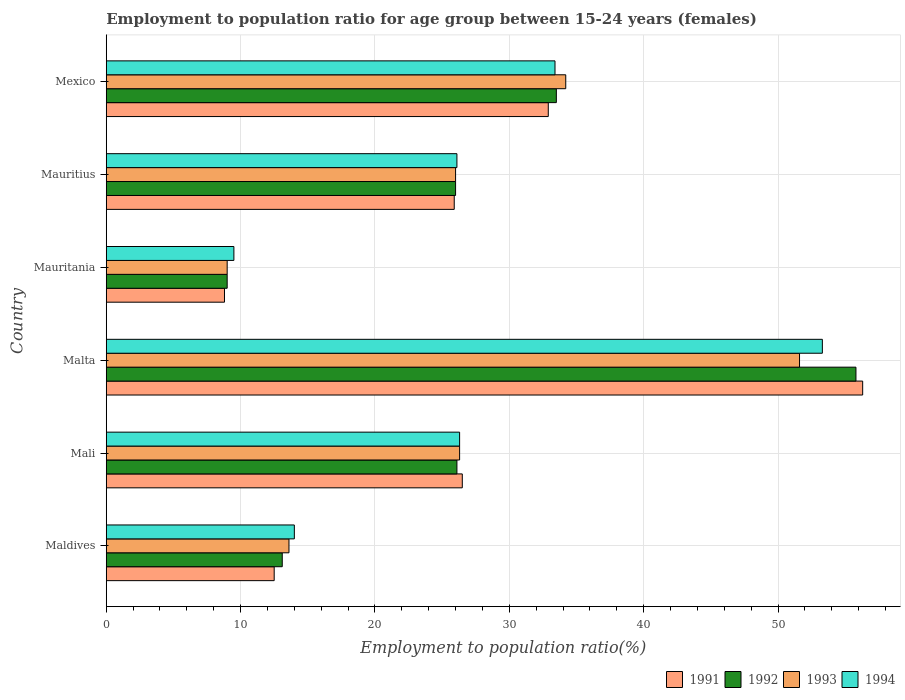How many groups of bars are there?
Your response must be concise. 6. Are the number of bars per tick equal to the number of legend labels?
Offer a terse response. Yes. What is the label of the 5th group of bars from the top?
Your answer should be very brief. Mali. What is the employment to population ratio in 1994 in Malta?
Give a very brief answer. 53.3. Across all countries, what is the maximum employment to population ratio in 1992?
Provide a short and direct response. 55.8. Across all countries, what is the minimum employment to population ratio in 1991?
Your answer should be compact. 8.8. In which country was the employment to population ratio in 1992 maximum?
Your answer should be very brief. Malta. In which country was the employment to population ratio in 1992 minimum?
Your answer should be very brief. Mauritania. What is the total employment to population ratio in 1994 in the graph?
Provide a short and direct response. 162.6. What is the difference between the employment to population ratio in 1991 in Mauritania and that in Mexico?
Your answer should be very brief. -24.1. What is the difference between the employment to population ratio in 1993 in Mauritania and the employment to population ratio in 1991 in Maldives?
Your response must be concise. -3.5. What is the average employment to population ratio in 1994 per country?
Offer a very short reply. 27.1. In how many countries, is the employment to population ratio in 1994 greater than 20 %?
Give a very brief answer. 4. What is the ratio of the employment to population ratio in 1993 in Mauritania to that in Mauritius?
Provide a succinct answer. 0.35. Is the employment to population ratio in 1992 in Malta less than that in Mauritania?
Provide a short and direct response. No. What is the difference between the highest and the second highest employment to population ratio in 1992?
Provide a succinct answer. 22.3. What is the difference between the highest and the lowest employment to population ratio in 1994?
Provide a short and direct response. 43.8. In how many countries, is the employment to population ratio in 1994 greater than the average employment to population ratio in 1994 taken over all countries?
Provide a short and direct response. 2. What does the 2nd bar from the top in Mauritania represents?
Offer a very short reply. 1993. What does the 2nd bar from the bottom in Malta represents?
Your answer should be very brief. 1992. How many bars are there?
Offer a very short reply. 24. What is the difference between two consecutive major ticks on the X-axis?
Make the answer very short. 10. Are the values on the major ticks of X-axis written in scientific E-notation?
Keep it short and to the point. No. How many legend labels are there?
Provide a short and direct response. 4. What is the title of the graph?
Offer a very short reply. Employment to population ratio for age group between 15-24 years (females). Does "1976" appear as one of the legend labels in the graph?
Provide a short and direct response. No. What is the Employment to population ratio(%) in 1991 in Maldives?
Make the answer very short. 12.5. What is the Employment to population ratio(%) in 1992 in Maldives?
Provide a short and direct response. 13.1. What is the Employment to population ratio(%) in 1993 in Maldives?
Your answer should be compact. 13.6. What is the Employment to population ratio(%) in 1994 in Maldives?
Provide a short and direct response. 14. What is the Employment to population ratio(%) in 1992 in Mali?
Your answer should be very brief. 26.1. What is the Employment to population ratio(%) in 1993 in Mali?
Ensure brevity in your answer.  26.3. What is the Employment to population ratio(%) in 1994 in Mali?
Your response must be concise. 26.3. What is the Employment to population ratio(%) in 1991 in Malta?
Provide a succinct answer. 56.3. What is the Employment to population ratio(%) in 1992 in Malta?
Keep it short and to the point. 55.8. What is the Employment to population ratio(%) of 1993 in Malta?
Keep it short and to the point. 51.6. What is the Employment to population ratio(%) of 1994 in Malta?
Your answer should be very brief. 53.3. What is the Employment to population ratio(%) of 1991 in Mauritania?
Your answer should be compact. 8.8. What is the Employment to population ratio(%) of 1992 in Mauritania?
Keep it short and to the point. 9. What is the Employment to population ratio(%) of 1994 in Mauritania?
Offer a very short reply. 9.5. What is the Employment to population ratio(%) of 1991 in Mauritius?
Keep it short and to the point. 25.9. What is the Employment to population ratio(%) of 1992 in Mauritius?
Ensure brevity in your answer.  26. What is the Employment to population ratio(%) of 1994 in Mauritius?
Make the answer very short. 26.1. What is the Employment to population ratio(%) of 1991 in Mexico?
Keep it short and to the point. 32.9. What is the Employment to population ratio(%) of 1992 in Mexico?
Ensure brevity in your answer.  33.5. What is the Employment to population ratio(%) in 1993 in Mexico?
Your answer should be compact. 34.2. What is the Employment to population ratio(%) of 1994 in Mexico?
Provide a short and direct response. 33.4. Across all countries, what is the maximum Employment to population ratio(%) in 1991?
Your answer should be compact. 56.3. Across all countries, what is the maximum Employment to population ratio(%) in 1992?
Your answer should be compact. 55.8. Across all countries, what is the maximum Employment to population ratio(%) of 1993?
Keep it short and to the point. 51.6. Across all countries, what is the maximum Employment to population ratio(%) of 1994?
Your response must be concise. 53.3. Across all countries, what is the minimum Employment to population ratio(%) in 1991?
Make the answer very short. 8.8. Across all countries, what is the minimum Employment to population ratio(%) in 1992?
Ensure brevity in your answer.  9. Across all countries, what is the minimum Employment to population ratio(%) in 1993?
Provide a succinct answer. 9. Across all countries, what is the minimum Employment to population ratio(%) in 1994?
Give a very brief answer. 9.5. What is the total Employment to population ratio(%) in 1991 in the graph?
Make the answer very short. 162.9. What is the total Employment to population ratio(%) in 1992 in the graph?
Give a very brief answer. 163.5. What is the total Employment to population ratio(%) of 1993 in the graph?
Offer a very short reply. 160.7. What is the total Employment to population ratio(%) in 1994 in the graph?
Offer a very short reply. 162.6. What is the difference between the Employment to population ratio(%) in 1991 in Maldives and that in Mali?
Offer a very short reply. -14. What is the difference between the Employment to population ratio(%) of 1992 in Maldives and that in Mali?
Provide a succinct answer. -13. What is the difference between the Employment to population ratio(%) of 1991 in Maldives and that in Malta?
Your answer should be very brief. -43.8. What is the difference between the Employment to population ratio(%) of 1992 in Maldives and that in Malta?
Offer a very short reply. -42.7. What is the difference between the Employment to population ratio(%) in 1993 in Maldives and that in Malta?
Make the answer very short. -38. What is the difference between the Employment to population ratio(%) in 1994 in Maldives and that in Malta?
Your answer should be compact. -39.3. What is the difference between the Employment to population ratio(%) of 1993 in Maldives and that in Mauritania?
Offer a terse response. 4.6. What is the difference between the Employment to population ratio(%) in 1994 in Maldives and that in Mauritius?
Your response must be concise. -12.1. What is the difference between the Employment to population ratio(%) of 1991 in Maldives and that in Mexico?
Keep it short and to the point. -20.4. What is the difference between the Employment to population ratio(%) in 1992 in Maldives and that in Mexico?
Provide a short and direct response. -20.4. What is the difference between the Employment to population ratio(%) of 1993 in Maldives and that in Mexico?
Offer a terse response. -20.6. What is the difference between the Employment to population ratio(%) in 1994 in Maldives and that in Mexico?
Your answer should be compact. -19.4. What is the difference between the Employment to population ratio(%) of 1991 in Mali and that in Malta?
Offer a terse response. -29.8. What is the difference between the Employment to population ratio(%) in 1992 in Mali and that in Malta?
Keep it short and to the point. -29.7. What is the difference between the Employment to population ratio(%) of 1993 in Mali and that in Malta?
Provide a short and direct response. -25.3. What is the difference between the Employment to population ratio(%) in 1994 in Mali and that in Malta?
Your answer should be compact. -27. What is the difference between the Employment to population ratio(%) of 1994 in Mali and that in Mauritania?
Provide a short and direct response. 16.8. What is the difference between the Employment to population ratio(%) in 1992 in Mali and that in Mauritius?
Ensure brevity in your answer.  0.1. What is the difference between the Employment to population ratio(%) of 1991 in Mali and that in Mexico?
Your answer should be compact. -6.4. What is the difference between the Employment to population ratio(%) of 1992 in Mali and that in Mexico?
Your answer should be compact. -7.4. What is the difference between the Employment to population ratio(%) of 1993 in Mali and that in Mexico?
Your answer should be compact. -7.9. What is the difference between the Employment to population ratio(%) in 1991 in Malta and that in Mauritania?
Your response must be concise. 47.5. What is the difference between the Employment to population ratio(%) in 1992 in Malta and that in Mauritania?
Your answer should be compact. 46.8. What is the difference between the Employment to population ratio(%) in 1993 in Malta and that in Mauritania?
Your answer should be very brief. 42.6. What is the difference between the Employment to population ratio(%) in 1994 in Malta and that in Mauritania?
Provide a short and direct response. 43.8. What is the difference between the Employment to population ratio(%) of 1991 in Malta and that in Mauritius?
Offer a very short reply. 30.4. What is the difference between the Employment to population ratio(%) in 1992 in Malta and that in Mauritius?
Ensure brevity in your answer.  29.8. What is the difference between the Employment to population ratio(%) of 1993 in Malta and that in Mauritius?
Give a very brief answer. 25.6. What is the difference between the Employment to population ratio(%) in 1994 in Malta and that in Mauritius?
Make the answer very short. 27.2. What is the difference between the Employment to population ratio(%) of 1991 in Malta and that in Mexico?
Ensure brevity in your answer.  23.4. What is the difference between the Employment to population ratio(%) of 1992 in Malta and that in Mexico?
Make the answer very short. 22.3. What is the difference between the Employment to population ratio(%) in 1993 in Malta and that in Mexico?
Make the answer very short. 17.4. What is the difference between the Employment to population ratio(%) in 1994 in Malta and that in Mexico?
Your answer should be compact. 19.9. What is the difference between the Employment to population ratio(%) of 1991 in Mauritania and that in Mauritius?
Provide a short and direct response. -17.1. What is the difference between the Employment to population ratio(%) of 1992 in Mauritania and that in Mauritius?
Offer a terse response. -17. What is the difference between the Employment to population ratio(%) in 1993 in Mauritania and that in Mauritius?
Give a very brief answer. -17. What is the difference between the Employment to population ratio(%) of 1994 in Mauritania and that in Mauritius?
Your answer should be very brief. -16.6. What is the difference between the Employment to population ratio(%) in 1991 in Mauritania and that in Mexico?
Give a very brief answer. -24.1. What is the difference between the Employment to population ratio(%) of 1992 in Mauritania and that in Mexico?
Give a very brief answer. -24.5. What is the difference between the Employment to population ratio(%) in 1993 in Mauritania and that in Mexico?
Offer a terse response. -25.2. What is the difference between the Employment to population ratio(%) in 1994 in Mauritania and that in Mexico?
Make the answer very short. -23.9. What is the difference between the Employment to population ratio(%) in 1991 in Mauritius and that in Mexico?
Keep it short and to the point. -7. What is the difference between the Employment to population ratio(%) of 1994 in Mauritius and that in Mexico?
Your answer should be compact. -7.3. What is the difference between the Employment to population ratio(%) in 1991 in Maldives and the Employment to population ratio(%) in 1994 in Mali?
Provide a short and direct response. -13.8. What is the difference between the Employment to population ratio(%) in 1992 in Maldives and the Employment to population ratio(%) in 1993 in Mali?
Offer a terse response. -13.2. What is the difference between the Employment to population ratio(%) of 1992 in Maldives and the Employment to population ratio(%) of 1994 in Mali?
Give a very brief answer. -13.2. What is the difference between the Employment to population ratio(%) of 1991 in Maldives and the Employment to population ratio(%) of 1992 in Malta?
Provide a short and direct response. -43.3. What is the difference between the Employment to population ratio(%) of 1991 in Maldives and the Employment to population ratio(%) of 1993 in Malta?
Your answer should be compact. -39.1. What is the difference between the Employment to population ratio(%) of 1991 in Maldives and the Employment to population ratio(%) of 1994 in Malta?
Ensure brevity in your answer.  -40.8. What is the difference between the Employment to population ratio(%) in 1992 in Maldives and the Employment to population ratio(%) in 1993 in Malta?
Give a very brief answer. -38.5. What is the difference between the Employment to population ratio(%) in 1992 in Maldives and the Employment to population ratio(%) in 1994 in Malta?
Your response must be concise. -40.2. What is the difference between the Employment to population ratio(%) of 1993 in Maldives and the Employment to population ratio(%) of 1994 in Malta?
Give a very brief answer. -39.7. What is the difference between the Employment to population ratio(%) in 1991 in Maldives and the Employment to population ratio(%) in 1993 in Mauritania?
Give a very brief answer. 3.5. What is the difference between the Employment to population ratio(%) of 1992 in Maldives and the Employment to population ratio(%) of 1993 in Mauritania?
Provide a succinct answer. 4.1. What is the difference between the Employment to population ratio(%) of 1991 in Maldives and the Employment to population ratio(%) of 1992 in Mauritius?
Give a very brief answer. -13.5. What is the difference between the Employment to population ratio(%) of 1991 in Maldives and the Employment to population ratio(%) of 1993 in Mauritius?
Your answer should be very brief. -13.5. What is the difference between the Employment to population ratio(%) of 1991 in Maldives and the Employment to population ratio(%) of 1993 in Mexico?
Make the answer very short. -21.7. What is the difference between the Employment to population ratio(%) of 1991 in Maldives and the Employment to population ratio(%) of 1994 in Mexico?
Offer a very short reply. -20.9. What is the difference between the Employment to population ratio(%) in 1992 in Maldives and the Employment to population ratio(%) in 1993 in Mexico?
Offer a very short reply. -21.1. What is the difference between the Employment to population ratio(%) of 1992 in Maldives and the Employment to population ratio(%) of 1994 in Mexico?
Make the answer very short. -20.3. What is the difference between the Employment to population ratio(%) of 1993 in Maldives and the Employment to population ratio(%) of 1994 in Mexico?
Make the answer very short. -19.8. What is the difference between the Employment to population ratio(%) of 1991 in Mali and the Employment to population ratio(%) of 1992 in Malta?
Provide a short and direct response. -29.3. What is the difference between the Employment to population ratio(%) in 1991 in Mali and the Employment to population ratio(%) in 1993 in Malta?
Keep it short and to the point. -25.1. What is the difference between the Employment to population ratio(%) of 1991 in Mali and the Employment to population ratio(%) of 1994 in Malta?
Ensure brevity in your answer.  -26.8. What is the difference between the Employment to population ratio(%) of 1992 in Mali and the Employment to population ratio(%) of 1993 in Malta?
Your answer should be compact. -25.5. What is the difference between the Employment to population ratio(%) in 1992 in Mali and the Employment to population ratio(%) in 1994 in Malta?
Make the answer very short. -27.2. What is the difference between the Employment to population ratio(%) of 1993 in Mali and the Employment to population ratio(%) of 1994 in Malta?
Your answer should be compact. -27. What is the difference between the Employment to population ratio(%) of 1991 in Mali and the Employment to population ratio(%) of 1994 in Mauritania?
Offer a very short reply. 17. What is the difference between the Employment to population ratio(%) of 1991 in Mali and the Employment to population ratio(%) of 1992 in Mauritius?
Give a very brief answer. 0.5. What is the difference between the Employment to population ratio(%) of 1991 in Mali and the Employment to population ratio(%) of 1993 in Mauritius?
Ensure brevity in your answer.  0.5. What is the difference between the Employment to population ratio(%) of 1991 in Mali and the Employment to population ratio(%) of 1994 in Mauritius?
Provide a short and direct response. 0.4. What is the difference between the Employment to population ratio(%) of 1992 in Mali and the Employment to population ratio(%) of 1993 in Mauritius?
Make the answer very short. 0.1. What is the difference between the Employment to population ratio(%) in 1992 in Mali and the Employment to population ratio(%) in 1994 in Mauritius?
Your response must be concise. 0. What is the difference between the Employment to population ratio(%) of 1993 in Mali and the Employment to population ratio(%) of 1994 in Mauritius?
Your response must be concise. 0.2. What is the difference between the Employment to population ratio(%) of 1992 in Mali and the Employment to population ratio(%) of 1993 in Mexico?
Provide a succinct answer. -8.1. What is the difference between the Employment to population ratio(%) in 1992 in Mali and the Employment to population ratio(%) in 1994 in Mexico?
Your answer should be compact. -7.3. What is the difference between the Employment to population ratio(%) in 1991 in Malta and the Employment to population ratio(%) in 1992 in Mauritania?
Your answer should be very brief. 47.3. What is the difference between the Employment to population ratio(%) of 1991 in Malta and the Employment to population ratio(%) of 1993 in Mauritania?
Give a very brief answer. 47.3. What is the difference between the Employment to population ratio(%) in 1991 in Malta and the Employment to population ratio(%) in 1994 in Mauritania?
Give a very brief answer. 46.8. What is the difference between the Employment to population ratio(%) of 1992 in Malta and the Employment to population ratio(%) of 1993 in Mauritania?
Your response must be concise. 46.8. What is the difference between the Employment to population ratio(%) of 1992 in Malta and the Employment to population ratio(%) of 1994 in Mauritania?
Ensure brevity in your answer.  46.3. What is the difference between the Employment to population ratio(%) in 1993 in Malta and the Employment to population ratio(%) in 1994 in Mauritania?
Keep it short and to the point. 42.1. What is the difference between the Employment to population ratio(%) of 1991 in Malta and the Employment to population ratio(%) of 1992 in Mauritius?
Give a very brief answer. 30.3. What is the difference between the Employment to population ratio(%) of 1991 in Malta and the Employment to population ratio(%) of 1993 in Mauritius?
Offer a terse response. 30.3. What is the difference between the Employment to population ratio(%) in 1991 in Malta and the Employment to population ratio(%) in 1994 in Mauritius?
Keep it short and to the point. 30.2. What is the difference between the Employment to population ratio(%) in 1992 in Malta and the Employment to population ratio(%) in 1993 in Mauritius?
Your response must be concise. 29.8. What is the difference between the Employment to population ratio(%) of 1992 in Malta and the Employment to population ratio(%) of 1994 in Mauritius?
Your response must be concise. 29.7. What is the difference between the Employment to population ratio(%) of 1993 in Malta and the Employment to population ratio(%) of 1994 in Mauritius?
Ensure brevity in your answer.  25.5. What is the difference between the Employment to population ratio(%) in 1991 in Malta and the Employment to population ratio(%) in 1992 in Mexico?
Give a very brief answer. 22.8. What is the difference between the Employment to population ratio(%) of 1991 in Malta and the Employment to population ratio(%) of 1993 in Mexico?
Provide a succinct answer. 22.1. What is the difference between the Employment to population ratio(%) in 1991 in Malta and the Employment to population ratio(%) in 1994 in Mexico?
Make the answer very short. 22.9. What is the difference between the Employment to population ratio(%) of 1992 in Malta and the Employment to population ratio(%) of 1993 in Mexico?
Your response must be concise. 21.6. What is the difference between the Employment to population ratio(%) of 1992 in Malta and the Employment to population ratio(%) of 1994 in Mexico?
Your answer should be compact. 22.4. What is the difference between the Employment to population ratio(%) in 1993 in Malta and the Employment to population ratio(%) in 1994 in Mexico?
Offer a very short reply. 18.2. What is the difference between the Employment to population ratio(%) of 1991 in Mauritania and the Employment to population ratio(%) of 1992 in Mauritius?
Your answer should be compact. -17.2. What is the difference between the Employment to population ratio(%) of 1991 in Mauritania and the Employment to population ratio(%) of 1993 in Mauritius?
Your response must be concise. -17.2. What is the difference between the Employment to population ratio(%) of 1991 in Mauritania and the Employment to population ratio(%) of 1994 in Mauritius?
Your response must be concise. -17.3. What is the difference between the Employment to population ratio(%) of 1992 in Mauritania and the Employment to population ratio(%) of 1994 in Mauritius?
Give a very brief answer. -17.1. What is the difference between the Employment to population ratio(%) in 1993 in Mauritania and the Employment to population ratio(%) in 1994 in Mauritius?
Your answer should be very brief. -17.1. What is the difference between the Employment to population ratio(%) of 1991 in Mauritania and the Employment to population ratio(%) of 1992 in Mexico?
Offer a very short reply. -24.7. What is the difference between the Employment to population ratio(%) in 1991 in Mauritania and the Employment to population ratio(%) in 1993 in Mexico?
Your answer should be very brief. -25.4. What is the difference between the Employment to population ratio(%) in 1991 in Mauritania and the Employment to population ratio(%) in 1994 in Mexico?
Offer a terse response. -24.6. What is the difference between the Employment to population ratio(%) of 1992 in Mauritania and the Employment to population ratio(%) of 1993 in Mexico?
Offer a terse response. -25.2. What is the difference between the Employment to population ratio(%) of 1992 in Mauritania and the Employment to population ratio(%) of 1994 in Mexico?
Give a very brief answer. -24.4. What is the difference between the Employment to population ratio(%) in 1993 in Mauritania and the Employment to population ratio(%) in 1994 in Mexico?
Your answer should be very brief. -24.4. What is the difference between the Employment to population ratio(%) in 1991 in Mauritius and the Employment to population ratio(%) in 1992 in Mexico?
Offer a terse response. -7.6. What is the difference between the Employment to population ratio(%) in 1992 in Mauritius and the Employment to population ratio(%) in 1993 in Mexico?
Your answer should be very brief. -8.2. What is the difference between the Employment to population ratio(%) in 1992 in Mauritius and the Employment to population ratio(%) in 1994 in Mexico?
Your answer should be compact. -7.4. What is the average Employment to population ratio(%) of 1991 per country?
Make the answer very short. 27.15. What is the average Employment to population ratio(%) of 1992 per country?
Provide a short and direct response. 27.25. What is the average Employment to population ratio(%) in 1993 per country?
Your answer should be very brief. 26.78. What is the average Employment to population ratio(%) in 1994 per country?
Offer a very short reply. 27.1. What is the difference between the Employment to population ratio(%) of 1991 and Employment to population ratio(%) of 1994 in Maldives?
Your answer should be very brief. -1.5. What is the difference between the Employment to population ratio(%) in 1993 and Employment to population ratio(%) in 1994 in Maldives?
Offer a terse response. -0.4. What is the difference between the Employment to population ratio(%) of 1991 and Employment to population ratio(%) of 1994 in Mali?
Your answer should be very brief. 0.2. What is the difference between the Employment to population ratio(%) of 1992 and Employment to population ratio(%) of 1993 in Mali?
Provide a short and direct response. -0.2. What is the difference between the Employment to population ratio(%) of 1992 and Employment to population ratio(%) of 1994 in Mali?
Your response must be concise. -0.2. What is the difference between the Employment to population ratio(%) in 1993 and Employment to population ratio(%) in 1994 in Mali?
Your response must be concise. 0. What is the difference between the Employment to population ratio(%) of 1991 and Employment to population ratio(%) of 1992 in Malta?
Provide a succinct answer. 0.5. What is the difference between the Employment to population ratio(%) of 1992 and Employment to population ratio(%) of 1993 in Malta?
Offer a terse response. 4.2. What is the difference between the Employment to population ratio(%) in 1992 and Employment to population ratio(%) in 1994 in Malta?
Your answer should be very brief. 2.5. What is the difference between the Employment to population ratio(%) in 1993 and Employment to population ratio(%) in 1994 in Malta?
Offer a very short reply. -1.7. What is the difference between the Employment to population ratio(%) of 1991 and Employment to population ratio(%) of 1992 in Mauritania?
Offer a terse response. -0.2. What is the difference between the Employment to population ratio(%) in 1991 and Employment to population ratio(%) in 1993 in Mauritania?
Offer a terse response. -0.2. What is the difference between the Employment to population ratio(%) of 1991 and Employment to population ratio(%) of 1994 in Mauritania?
Offer a very short reply. -0.7. What is the difference between the Employment to population ratio(%) in 1992 and Employment to population ratio(%) in 1994 in Mauritania?
Your answer should be compact. -0.5. What is the difference between the Employment to population ratio(%) in 1993 and Employment to population ratio(%) in 1994 in Mauritania?
Provide a succinct answer. -0.5. What is the difference between the Employment to population ratio(%) of 1991 and Employment to population ratio(%) of 1994 in Mauritius?
Give a very brief answer. -0.2. What is the difference between the Employment to population ratio(%) in 1993 and Employment to population ratio(%) in 1994 in Mauritius?
Offer a terse response. -0.1. What is the difference between the Employment to population ratio(%) of 1991 and Employment to population ratio(%) of 1992 in Mexico?
Give a very brief answer. -0.6. What is the difference between the Employment to population ratio(%) in 1991 and Employment to population ratio(%) in 1994 in Mexico?
Ensure brevity in your answer.  -0.5. What is the difference between the Employment to population ratio(%) in 1992 and Employment to population ratio(%) in 1993 in Mexico?
Your answer should be very brief. -0.7. What is the ratio of the Employment to population ratio(%) of 1991 in Maldives to that in Mali?
Your response must be concise. 0.47. What is the ratio of the Employment to population ratio(%) of 1992 in Maldives to that in Mali?
Offer a very short reply. 0.5. What is the ratio of the Employment to population ratio(%) of 1993 in Maldives to that in Mali?
Your answer should be very brief. 0.52. What is the ratio of the Employment to population ratio(%) of 1994 in Maldives to that in Mali?
Offer a terse response. 0.53. What is the ratio of the Employment to population ratio(%) of 1991 in Maldives to that in Malta?
Your answer should be very brief. 0.22. What is the ratio of the Employment to population ratio(%) of 1992 in Maldives to that in Malta?
Ensure brevity in your answer.  0.23. What is the ratio of the Employment to population ratio(%) of 1993 in Maldives to that in Malta?
Provide a succinct answer. 0.26. What is the ratio of the Employment to population ratio(%) of 1994 in Maldives to that in Malta?
Make the answer very short. 0.26. What is the ratio of the Employment to population ratio(%) in 1991 in Maldives to that in Mauritania?
Provide a short and direct response. 1.42. What is the ratio of the Employment to population ratio(%) of 1992 in Maldives to that in Mauritania?
Provide a succinct answer. 1.46. What is the ratio of the Employment to population ratio(%) in 1993 in Maldives to that in Mauritania?
Give a very brief answer. 1.51. What is the ratio of the Employment to population ratio(%) of 1994 in Maldives to that in Mauritania?
Keep it short and to the point. 1.47. What is the ratio of the Employment to population ratio(%) of 1991 in Maldives to that in Mauritius?
Keep it short and to the point. 0.48. What is the ratio of the Employment to population ratio(%) in 1992 in Maldives to that in Mauritius?
Offer a terse response. 0.5. What is the ratio of the Employment to population ratio(%) of 1993 in Maldives to that in Mauritius?
Give a very brief answer. 0.52. What is the ratio of the Employment to population ratio(%) of 1994 in Maldives to that in Mauritius?
Your answer should be compact. 0.54. What is the ratio of the Employment to population ratio(%) of 1991 in Maldives to that in Mexico?
Make the answer very short. 0.38. What is the ratio of the Employment to population ratio(%) of 1992 in Maldives to that in Mexico?
Provide a short and direct response. 0.39. What is the ratio of the Employment to population ratio(%) of 1993 in Maldives to that in Mexico?
Ensure brevity in your answer.  0.4. What is the ratio of the Employment to population ratio(%) of 1994 in Maldives to that in Mexico?
Your answer should be very brief. 0.42. What is the ratio of the Employment to population ratio(%) of 1991 in Mali to that in Malta?
Offer a terse response. 0.47. What is the ratio of the Employment to population ratio(%) of 1992 in Mali to that in Malta?
Keep it short and to the point. 0.47. What is the ratio of the Employment to population ratio(%) of 1993 in Mali to that in Malta?
Provide a short and direct response. 0.51. What is the ratio of the Employment to population ratio(%) in 1994 in Mali to that in Malta?
Your answer should be very brief. 0.49. What is the ratio of the Employment to population ratio(%) of 1991 in Mali to that in Mauritania?
Provide a succinct answer. 3.01. What is the ratio of the Employment to population ratio(%) of 1993 in Mali to that in Mauritania?
Offer a terse response. 2.92. What is the ratio of the Employment to population ratio(%) in 1994 in Mali to that in Mauritania?
Offer a terse response. 2.77. What is the ratio of the Employment to population ratio(%) of 1991 in Mali to that in Mauritius?
Your answer should be compact. 1.02. What is the ratio of the Employment to population ratio(%) in 1992 in Mali to that in Mauritius?
Your answer should be compact. 1. What is the ratio of the Employment to population ratio(%) in 1993 in Mali to that in Mauritius?
Provide a succinct answer. 1.01. What is the ratio of the Employment to population ratio(%) of 1994 in Mali to that in Mauritius?
Offer a terse response. 1.01. What is the ratio of the Employment to population ratio(%) in 1991 in Mali to that in Mexico?
Provide a succinct answer. 0.81. What is the ratio of the Employment to population ratio(%) of 1992 in Mali to that in Mexico?
Your response must be concise. 0.78. What is the ratio of the Employment to population ratio(%) in 1993 in Mali to that in Mexico?
Your answer should be very brief. 0.77. What is the ratio of the Employment to population ratio(%) in 1994 in Mali to that in Mexico?
Offer a very short reply. 0.79. What is the ratio of the Employment to population ratio(%) in 1991 in Malta to that in Mauritania?
Your answer should be compact. 6.4. What is the ratio of the Employment to population ratio(%) of 1992 in Malta to that in Mauritania?
Your answer should be compact. 6.2. What is the ratio of the Employment to population ratio(%) in 1993 in Malta to that in Mauritania?
Offer a terse response. 5.73. What is the ratio of the Employment to population ratio(%) in 1994 in Malta to that in Mauritania?
Give a very brief answer. 5.61. What is the ratio of the Employment to population ratio(%) in 1991 in Malta to that in Mauritius?
Ensure brevity in your answer.  2.17. What is the ratio of the Employment to population ratio(%) in 1992 in Malta to that in Mauritius?
Make the answer very short. 2.15. What is the ratio of the Employment to population ratio(%) of 1993 in Malta to that in Mauritius?
Your answer should be compact. 1.98. What is the ratio of the Employment to population ratio(%) of 1994 in Malta to that in Mauritius?
Provide a short and direct response. 2.04. What is the ratio of the Employment to population ratio(%) of 1991 in Malta to that in Mexico?
Your answer should be compact. 1.71. What is the ratio of the Employment to population ratio(%) of 1992 in Malta to that in Mexico?
Offer a terse response. 1.67. What is the ratio of the Employment to population ratio(%) of 1993 in Malta to that in Mexico?
Give a very brief answer. 1.51. What is the ratio of the Employment to population ratio(%) in 1994 in Malta to that in Mexico?
Offer a very short reply. 1.6. What is the ratio of the Employment to population ratio(%) of 1991 in Mauritania to that in Mauritius?
Make the answer very short. 0.34. What is the ratio of the Employment to population ratio(%) of 1992 in Mauritania to that in Mauritius?
Your response must be concise. 0.35. What is the ratio of the Employment to population ratio(%) of 1993 in Mauritania to that in Mauritius?
Give a very brief answer. 0.35. What is the ratio of the Employment to population ratio(%) in 1994 in Mauritania to that in Mauritius?
Offer a very short reply. 0.36. What is the ratio of the Employment to population ratio(%) of 1991 in Mauritania to that in Mexico?
Your response must be concise. 0.27. What is the ratio of the Employment to population ratio(%) in 1992 in Mauritania to that in Mexico?
Your answer should be very brief. 0.27. What is the ratio of the Employment to population ratio(%) of 1993 in Mauritania to that in Mexico?
Give a very brief answer. 0.26. What is the ratio of the Employment to population ratio(%) of 1994 in Mauritania to that in Mexico?
Make the answer very short. 0.28. What is the ratio of the Employment to population ratio(%) of 1991 in Mauritius to that in Mexico?
Your response must be concise. 0.79. What is the ratio of the Employment to population ratio(%) in 1992 in Mauritius to that in Mexico?
Provide a succinct answer. 0.78. What is the ratio of the Employment to population ratio(%) of 1993 in Mauritius to that in Mexico?
Offer a very short reply. 0.76. What is the ratio of the Employment to population ratio(%) in 1994 in Mauritius to that in Mexico?
Offer a very short reply. 0.78. What is the difference between the highest and the second highest Employment to population ratio(%) of 1991?
Provide a short and direct response. 23.4. What is the difference between the highest and the second highest Employment to population ratio(%) of 1992?
Provide a short and direct response. 22.3. What is the difference between the highest and the lowest Employment to population ratio(%) of 1991?
Give a very brief answer. 47.5. What is the difference between the highest and the lowest Employment to population ratio(%) in 1992?
Offer a very short reply. 46.8. What is the difference between the highest and the lowest Employment to population ratio(%) of 1993?
Give a very brief answer. 42.6. What is the difference between the highest and the lowest Employment to population ratio(%) in 1994?
Provide a short and direct response. 43.8. 